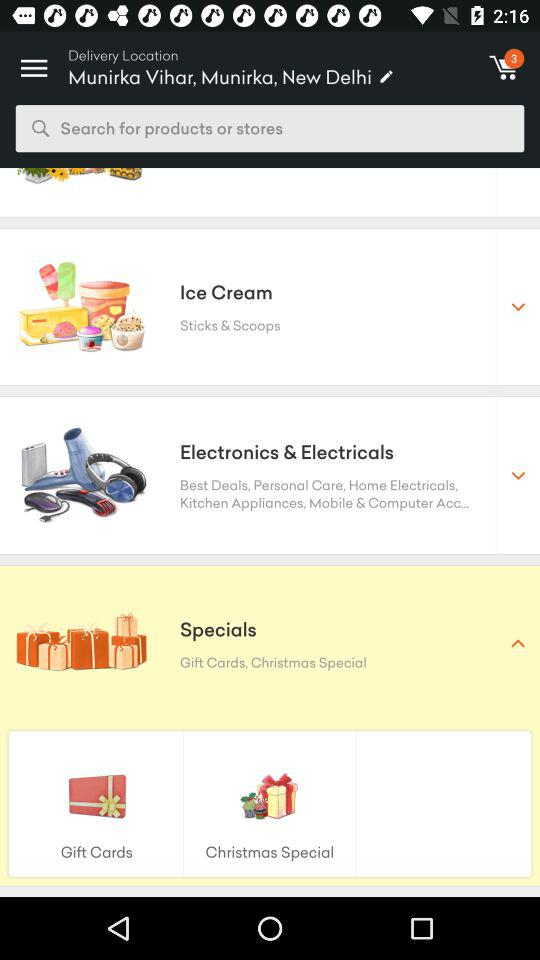How many things are added to the cart? There are 3 things added to the cart. 